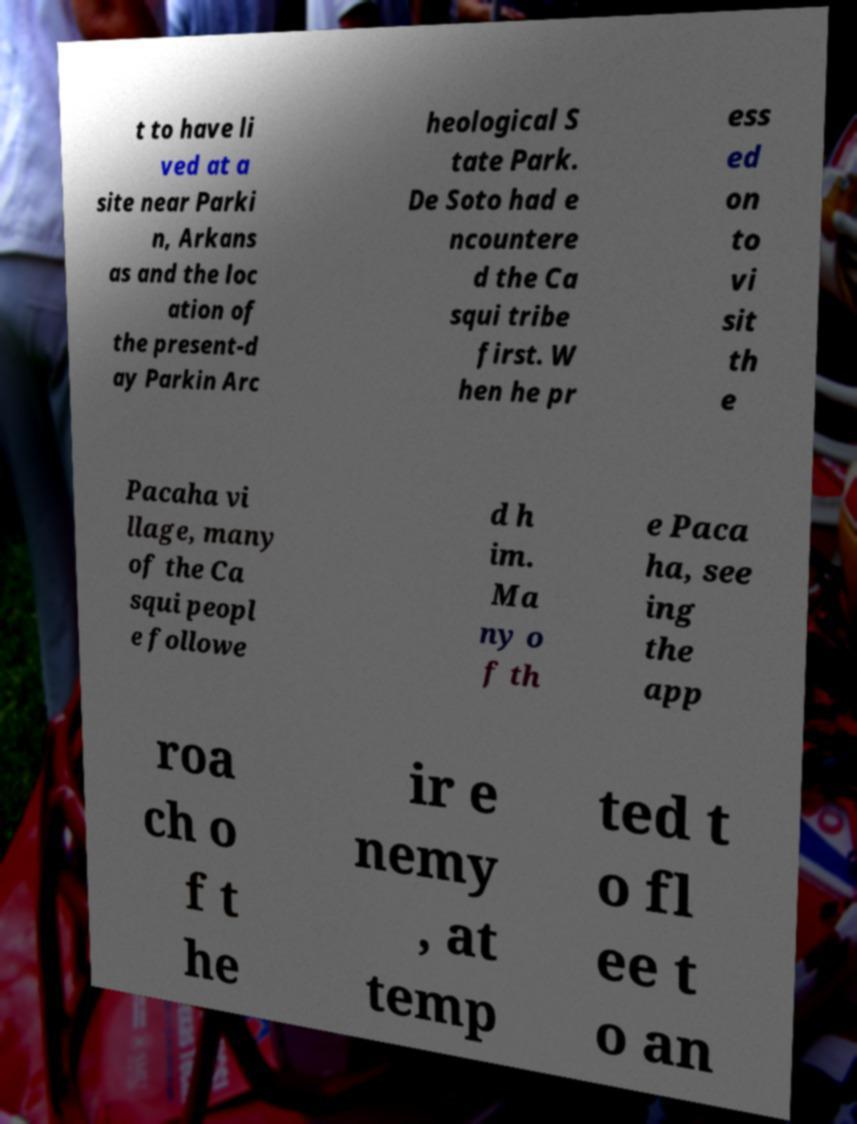For documentation purposes, I need the text within this image transcribed. Could you provide that? t to have li ved at a site near Parki n, Arkans as and the loc ation of the present-d ay Parkin Arc heological S tate Park. De Soto had e ncountere d the Ca squi tribe first. W hen he pr ess ed on to vi sit th e Pacaha vi llage, many of the Ca squi peopl e followe d h im. Ma ny o f th e Paca ha, see ing the app roa ch o f t he ir e nemy , at temp ted t o fl ee t o an 